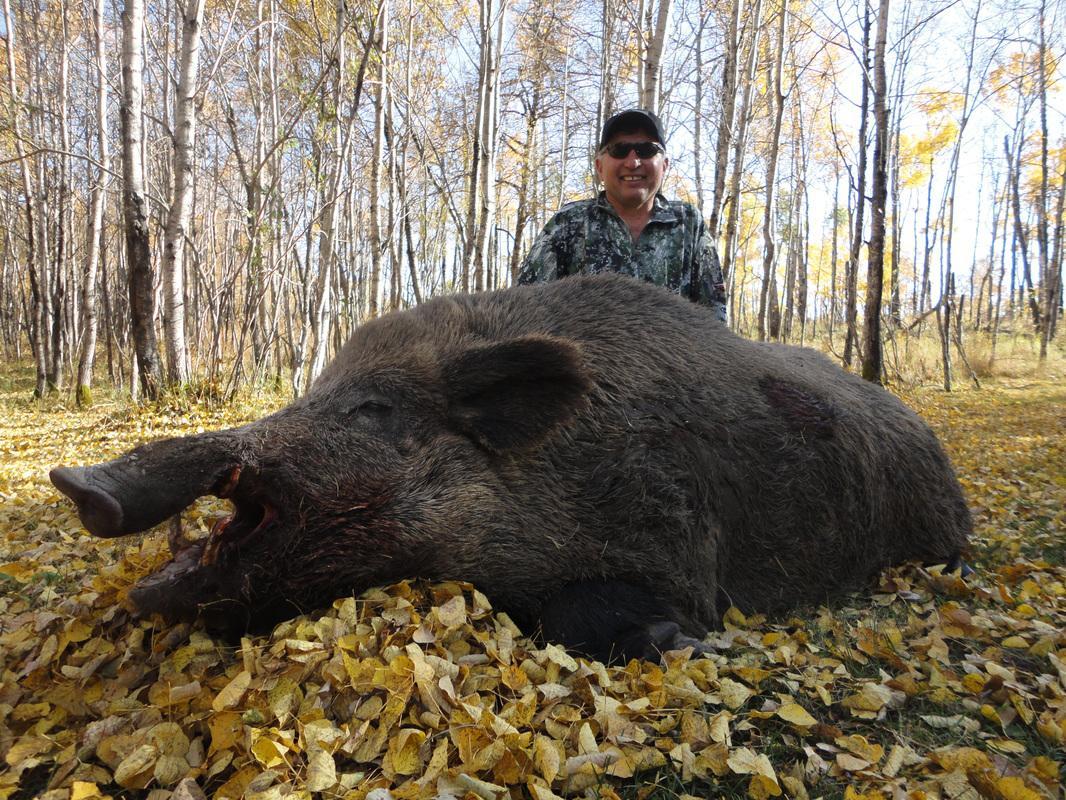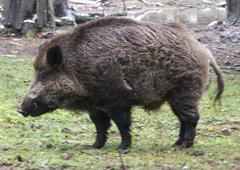The first image is the image on the left, the second image is the image on the right. For the images shown, is this caption "There is at least one hunter with their gun standing next to a dead boar." true? Answer yes or no. No. 